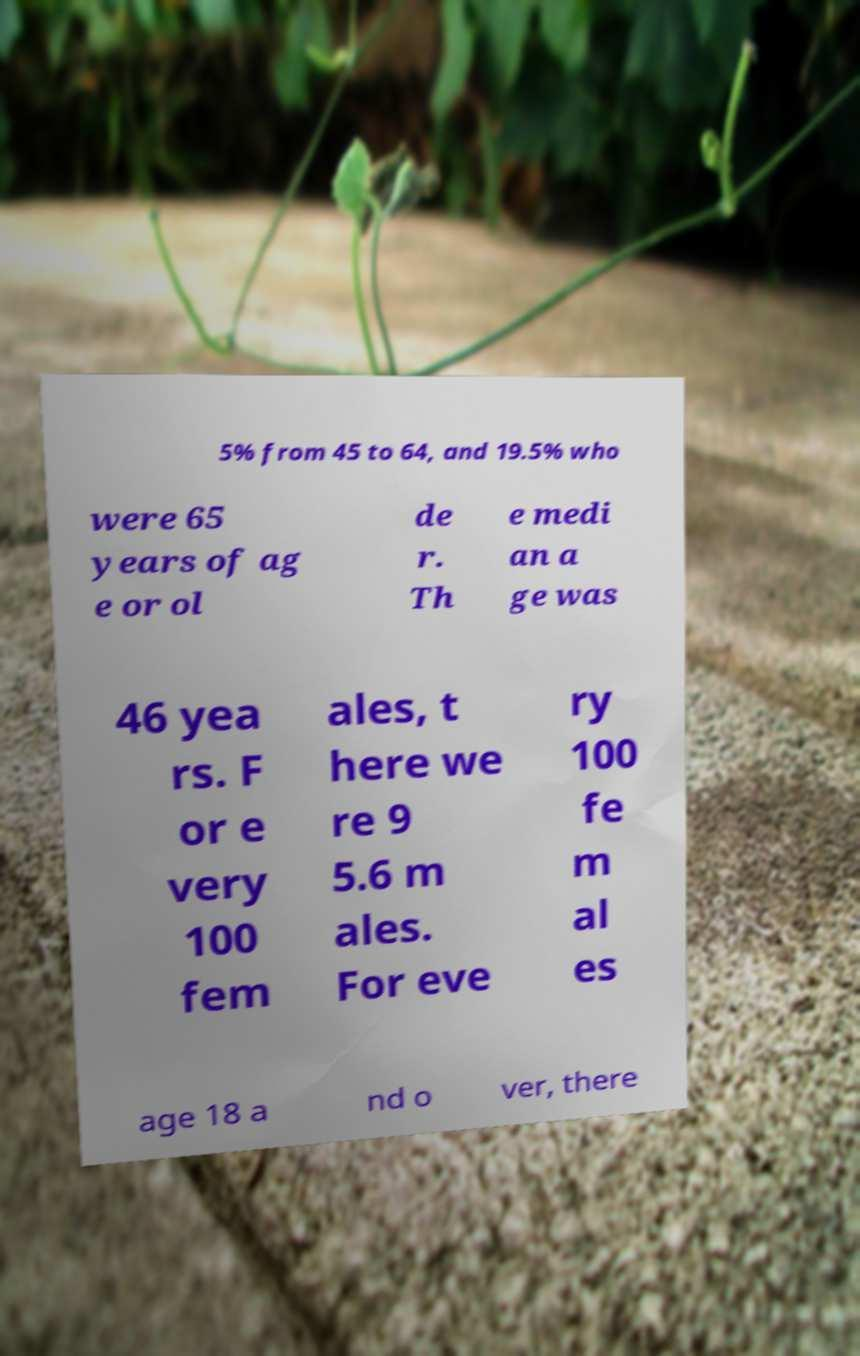For documentation purposes, I need the text within this image transcribed. Could you provide that? 5% from 45 to 64, and 19.5% who were 65 years of ag e or ol de r. Th e medi an a ge was 46 yea rs. F or e very 100 fem ales, t here we re 9 5.6 m ales. For eve ry 100 fe m al es age 18 a nd o ver, there 